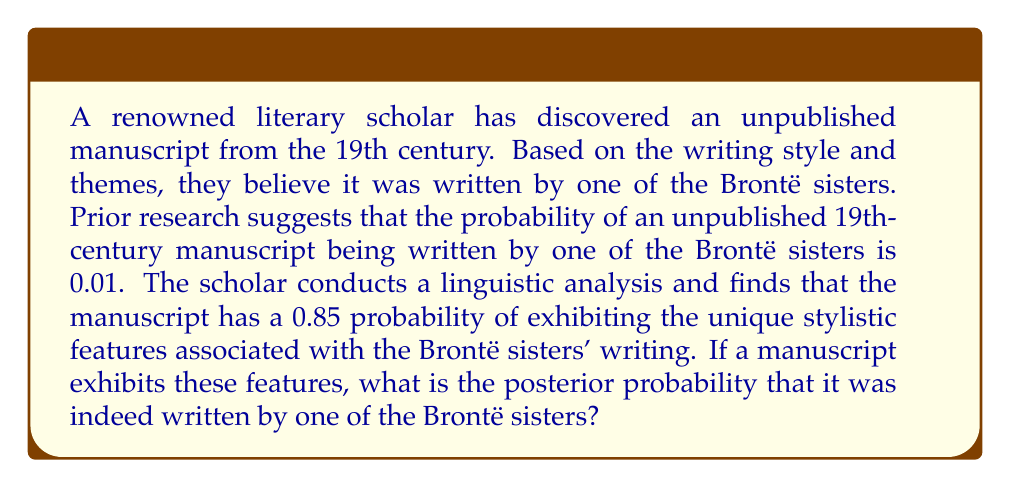Provide a solution to this math problem. To solve this problem, we'll use Bayes' theorem, which is fundamental in updating probabilities based on new evidence. Let's define our events:

A: The manuscript was written by one of the Brontë sisters
B: The manuscript exhibits the unique stylistic features of the Brontë sisters

Given:
P(A) = 0.01 (prior probability)
P(B|A) = 0.85 (likelihood)
P(B|not A) = 0.15 (assuming the complement, as the features are unique to the Brontës)

Bayes' theorem states:

$$ P(A|B) = \frac{P(B|A) \cdot P(A)}{P(B)} $$

To find P(B), we use the law of total probability:

$$ P(B) = P(B|A) \cdot P(A) + P(B|not A) \cdot P(not A) $$

Step 1: Calculate P(not A)
$$ P(not A) = 1 - P(A) = 1 - 0.01 = 0.99 $$

Step 2: Calculate P(B)
$$ P(B) = 0.85 \cdot 0.01 + 0.15 \cdot 0.99 = 0.0085 + 0.1485 = 0.157 $$

Step 3: Apply Bayes' theorem
$$ P(A|B) = \frac{0.85 \cdot 0.01}{0.157} = \frac{0.0085}{0.157} \approx 0.0541 $$

Therefore, the posterior probability that the manuscript was written by one of the Brontë sisters, given that it exhibits their unique stylistic features, is approximately 0.0541 or 5.41%.
Answer: The posterior probability that the manuscript was written by one of the Brontë sisters is approximately 0.0541 or 5.41%. 